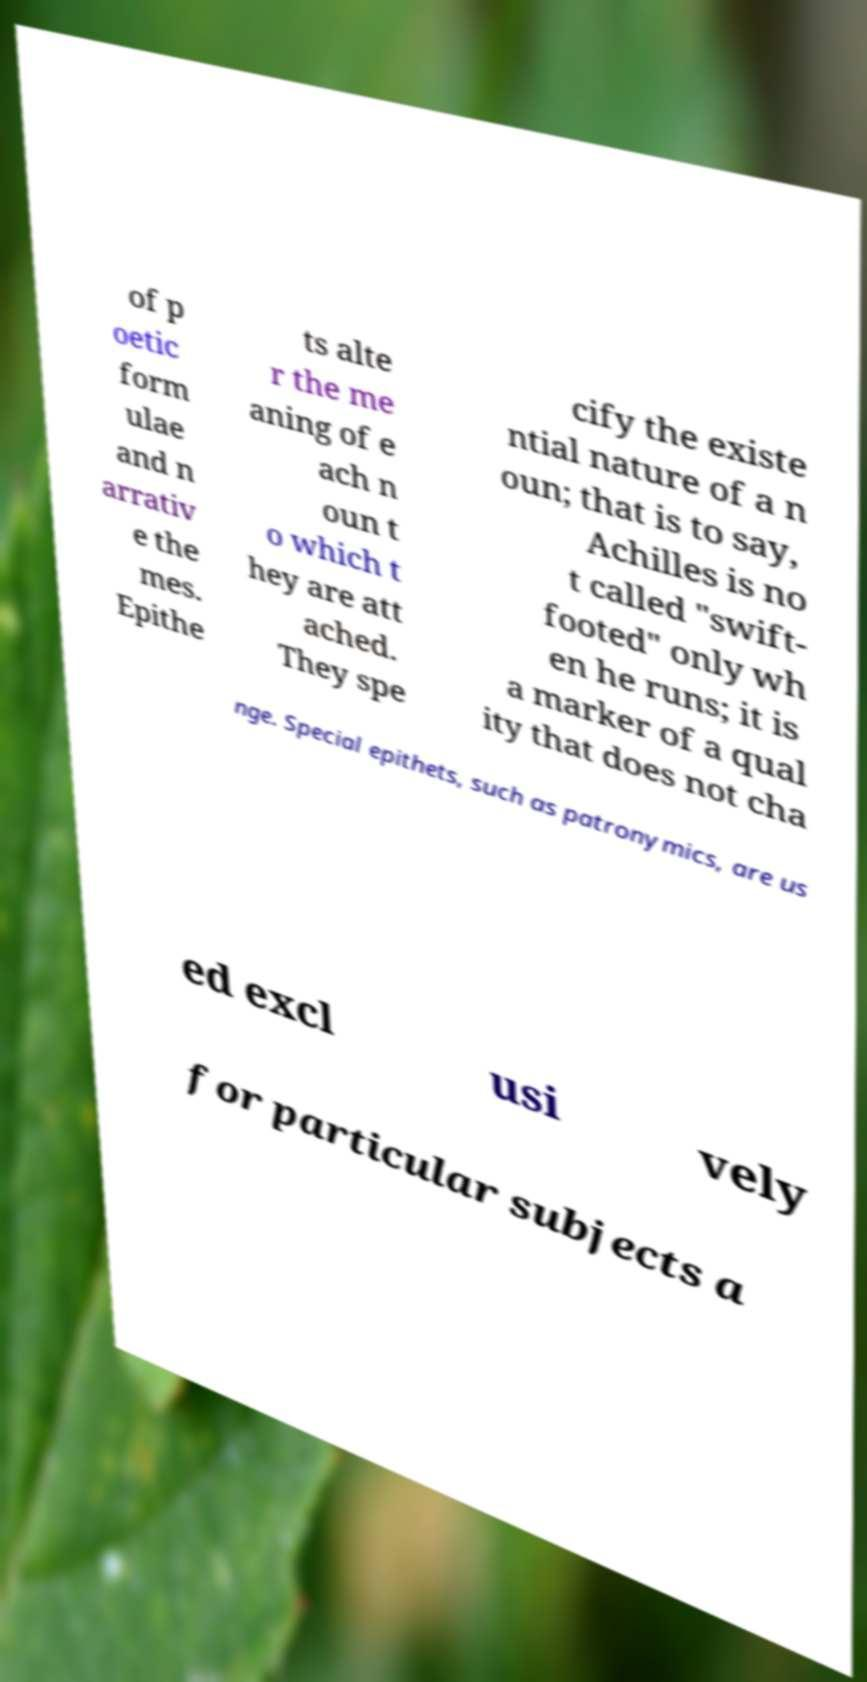Please identify and transcribe the text found in this image. of p oetic form ulae and n arrativ e the mes. Epithe ts alte r the me aning of e ach n oun t o which t hey are att ached. They spe cify the existe ntial nature of a n oun; that is to say, Achilles is no t called "swift- footed" only wh en he runs; it is a marker of a qual ity that does not cha nge. Special epithets, such as patronymics, are us ed excl usi vely for particular subjects a 